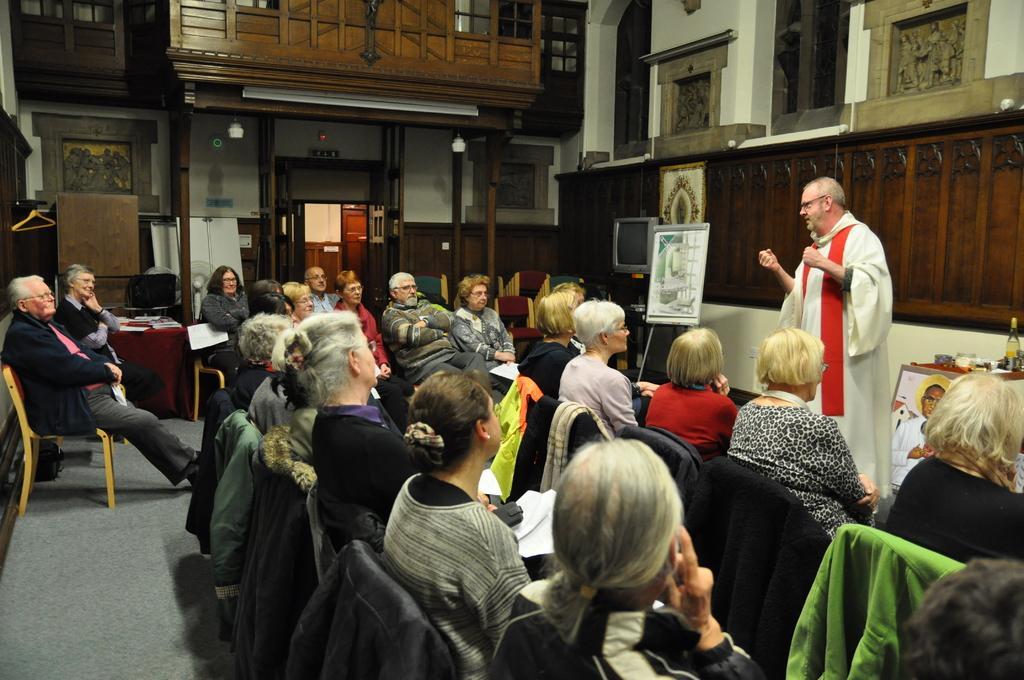In one or two sentences, can you explain what this image depicts? In this image there are people sitting on chairs and a man is standing, behind the man there is a wall, in the background there is a wall for that wall there is a door. 